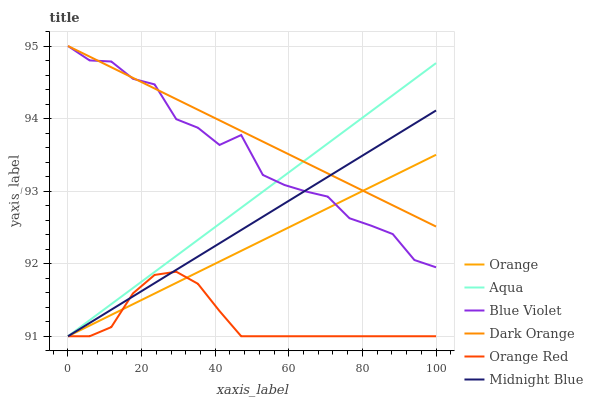Does Orange Red have the minimum area under the curve?
Answer yes or no. Yes. Does Dark Orange have the maximum area under the curve?
Answer yes or no. Yes. Does Midnight Blue have the minimum area under the curve?
Answer yes or no. No. Does Midnight Blue have the maximum area under the curve?
Answer yes or no. No. Is Dark Orange the smoothest?
Answer yes or no. Yes. Is Blue Violet the roughest?
Answer yes or no. Yes. Is Midnight Blue the smoothest?
Answer yes or no. No. Is Midnight Blue the roughest?
Answer yes or no. No. Does Blue Violet have the lowest value?
Answer yes or no. No. Does Midnight Blue have the highest value?
Answer yes or no. No. Is Orange Red less than Blue Violet?
Answer yes or no. Yes. Is Dark Orange greater than Orange Red?
Answer yes or no. Yes. Does Orange Red intersect Blue Violet?
Answer yes or no. No. 